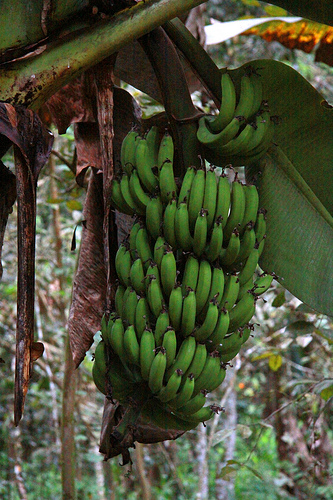Can you describe the entire scene in the image? The image depicts a lush, verdant environment with a bunch of green bananas hanging from a large banana tree. The bananas appear healthy and are clustered together tightly. Surrounding the bunch, there are large banana leaves, some of which appear to be dried out and hanging down. The background suggests a dense forest, with various shades of green adding depth to the scene. What do you think is happening in this image? It looks like the bananas are in a stage of growth and ripening, soon to be harvested. The healthy green color suggests that they are still maturing, and the environment seems to support this with ample foliage around. The presence of dried leaves indicates a natural aging process of the plant, which could mean it’s an older plant providing sustenance through its fruits. Imagine the scene if this was part of a magical forest. What would the magical elements be? In a magical forest, these green bananas might glow with an ethereal light, giving off a soft, bioluminescent glow. The large leaves could shimmer with an iridescent hue, and the entire bunch might sing in harmony with the wind, almost as if they were communicating. Surrounding this magical banana tree, there could be tiny fairy creatures flitting about, dusting the air with sparkling spores. The forest itself might have a surreal quality, with vibrant colors and fantastical creatures like unicorns or talking animals all contributing to the enchantment. 